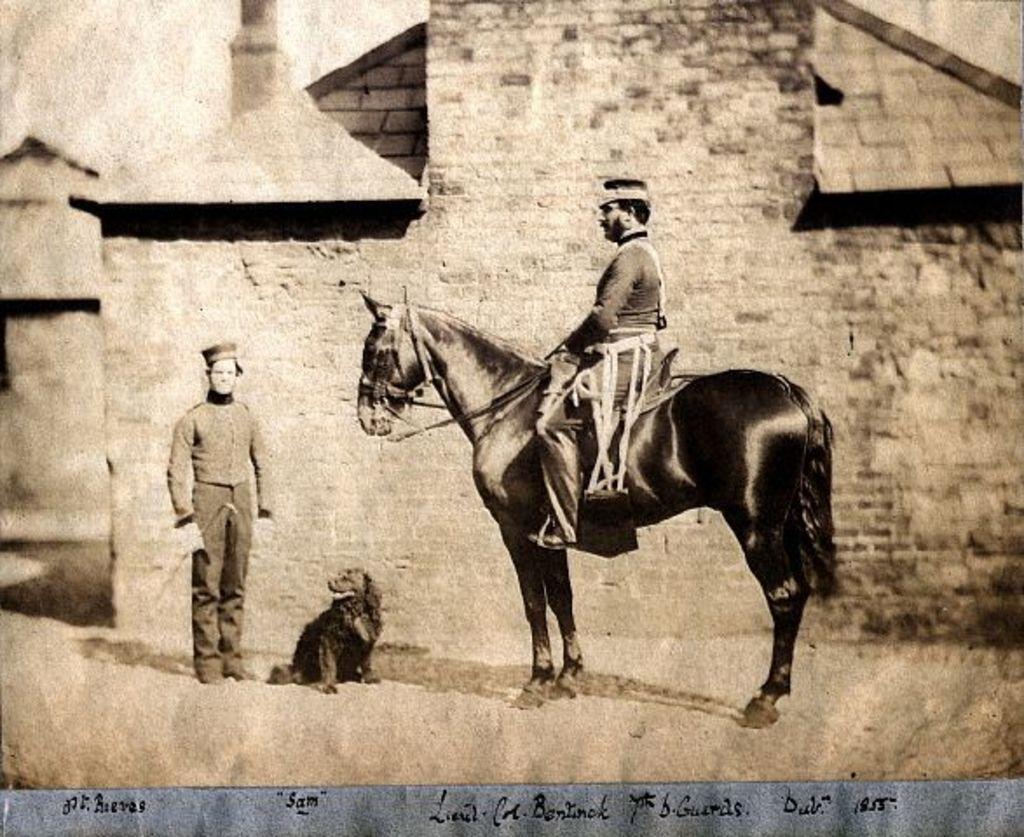Can you describe this image briefly? In this image I can see a person wearing a hat is sitting on the horse, I can see a dog on the floor and the person wearing a uniform and the hat is standing and holding stick in his hand. In the background i can see the building and the sky. 